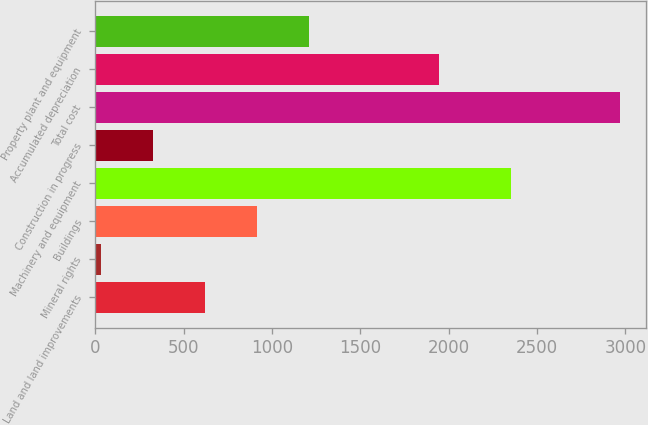Convert chart to OTSL. <chart><loc_0><loc_0><loc_500><loc_500><bar_chart><fcel>Land and land improvements<fcel>Mineral rights<fcel>Buildings<fcel>Machinery and equipment<fcel>Construction in progress<fcel>Total cost<fcel>Accumulated depreciation<fcel>Property plant and equipment<nl><fcel>620.74<fcel>33.8<fcel>914.21<fcel>2354.8<fcel>327.27<fcel>2968.5<fcel>1943.4<fcel>1207.68<nl></chart> 